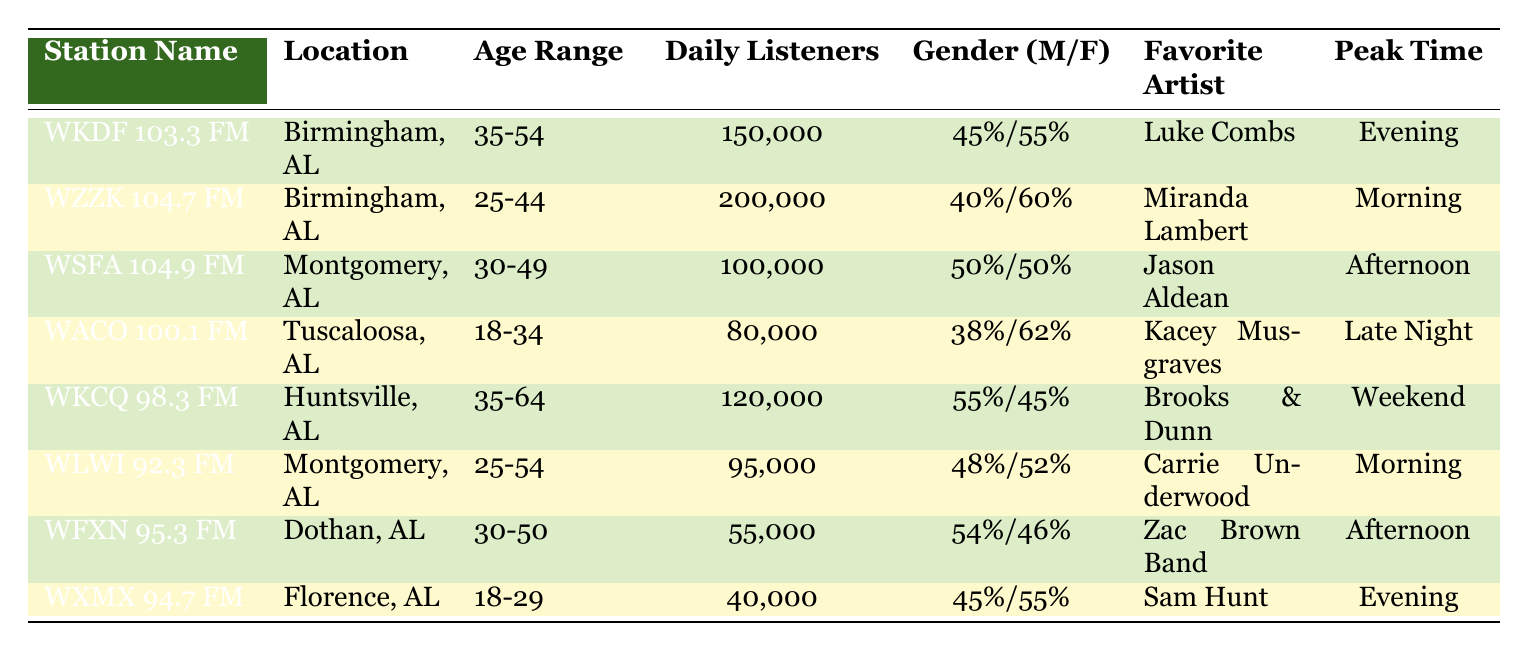What is the station with the highest average daily listeners? Looking through the "average_daily_listeners" column, WZZK 104.7 FM has 200,000 listeners, which is higher than all other stations listed.
Answer: WZZK 104.7 FM How many stations have an equal gender distribution of listeners? By examining the "gender_distribution" column, WSFA 104.9 FM has a gender distribution of 50% male and 50% female. No other stations have this distribution.
Answer: 1 station What is the total average daily listeners across all stations listed? To find the total average daily listeners, add the listeners from all stations: 150,000 + 200,000 + 100,000 + 80,000 + 120,000 + 95,000 + 55,000 + 40,000 = 840,000.
Answer: 840,000 Which station has the favorite artist Miranda Lambert and what is its location? Looking at the "favorite_artist" column, WZZK 104.7 FM has Miranda Lambert as its favorite artist. The location of this station is Birmingham, AL.
Answer: WZZK 104.7 FM, Birmingham, AL Is the favorite artist for the station with the most listeners a male or female artist? The station with the most listeners is WZZK 104.7 FM, which has Miranda Lambert as its favorite artist, a female artist. Therefore, the answer is female.
Answer: Female Which age range listens to WACO 100.1 FM, and what is the average number of listeners for that station? The "listener_age_range" for WACO 100.1 FM is 18-34, and the "average_daily_listeners" for that station is 80,000.
Answer: 18-34, 80,000 What is the average listener age range for stations that broadcast in the morning? The stations that broadcast in the morning are WZZK 104.7 FM (25-44) and WLWI 92.3 FM (25-54). The average age range can be determined by analyzing the midpoints of both ranges: (25+44)/2 = 34.5 and (25+54)/2 = 39.5. Their average is (34.5 + 39.5)/2 = 37.
Answer: 37 In which location is WXMX 94.7 FM based, and what is its listening time? WXMX 94.7 FM is located in Florence, AL, and its "listening_time" is noted as Evening.
Answer: Florence, AL, Evening 